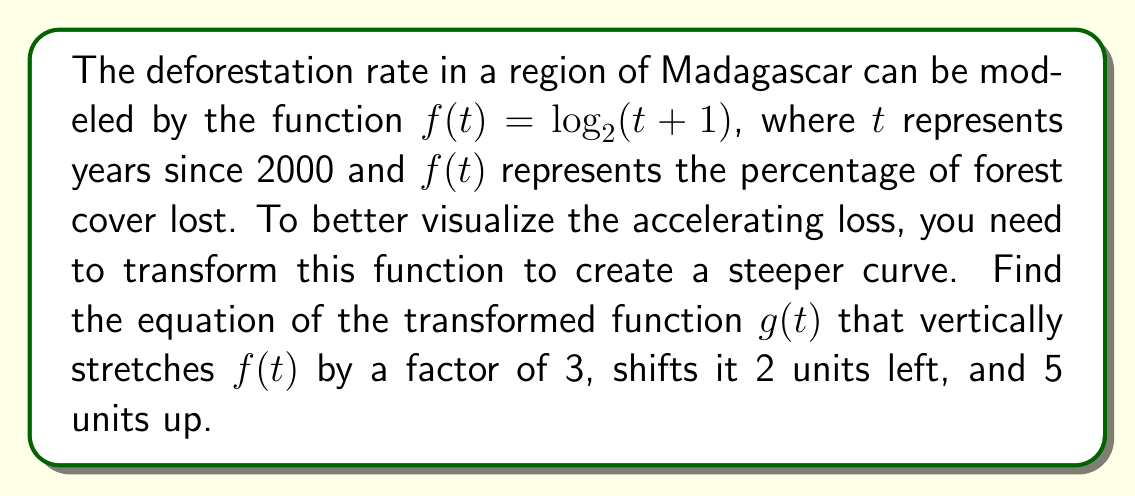Can you answer this question? Let's apply the transformations step-by-step:

1. Start with the original function: $f(t) = \log_2(t+1)$

2. Vertical stretch by a factor of 3:
   $3\log_2(t+1)$

3. Shift 2 units left:
   Replace $t$ with $(t+2)$
   $3\log_2((t+2)+1) = 3\log_2(t+3)$

4. Shift 5 units up:
   Add 5 to the entire function
   $3\log_2(t+3) + 5$

Therefore, the transformed function $g(t)$ is:

$$g(t) = 3\log_2(t+3) + 5$$

This transformation will create a steeper curve that starts higher on the y-axis, helping to visualize the accelerating deforestation rate in the Madagascar region.
Answer: $g(t) = 3\log_2(t+3) + 5$ 